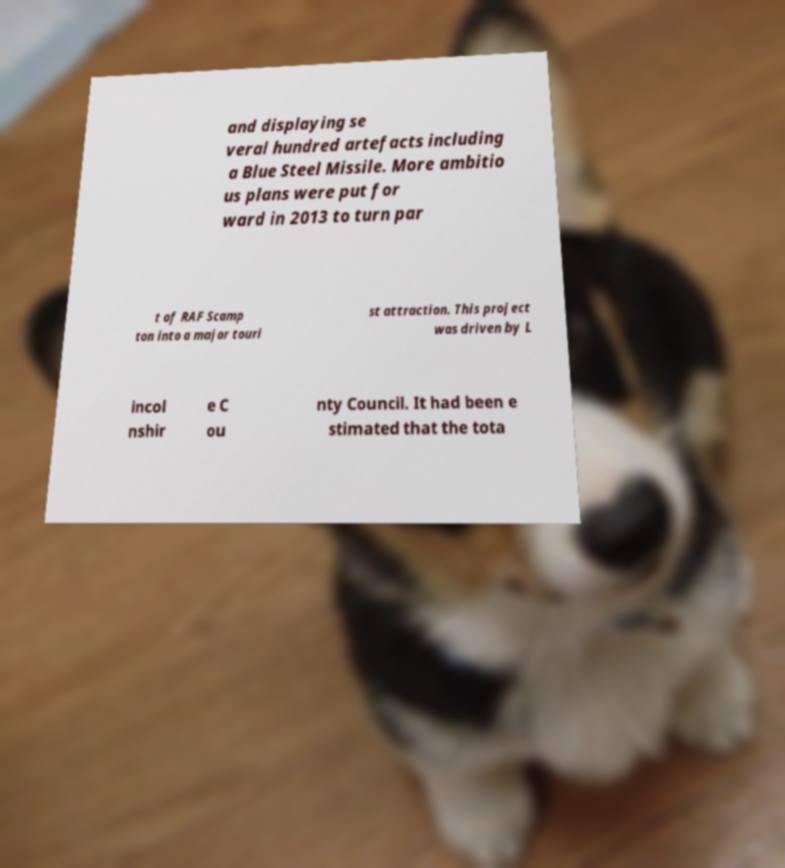There's text embedded in this image that I need extracted. Can you transcribe it verbatim? and displaying se veral hundred artefacts including a Blue Steel Missile. More ambitio us plans were put for ward in 2013 to turn par t of RAF Scamp ton into a major touri st attraction. This project was driven by L incol nshir e C ou nty Council. It had been e stimated that the tota 